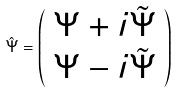Convert formula to latex. <formula><loc_0><loc_0><loc_500><loc_500>\hat { \Psi } = \left ( \begin{array} { c } { \Psi } + i { \tilde { \Psi } } \\ { \Psi } - i { \tilde { \Psi } } \end{array} \right )</formula> 